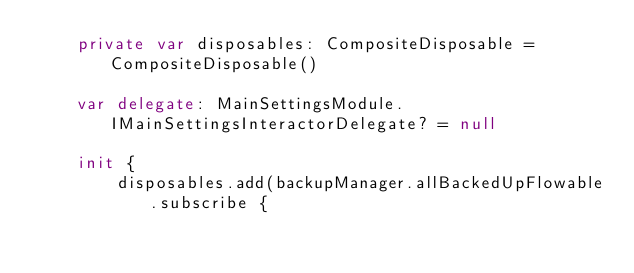Convert code to text. <code><loc_0><loc_0><loc_500><loc_500><_Kotlin_>    private var disposables: CompositeDisposable = CompositeDisposable()

    var delegate: MainSettingsModule.IMainSettingsInteractorDelegate? = null

    init {
        disposables.add(backupManager.allBackedUpFlowable.subscribe {</code> 